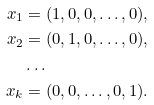<formula> <loc_0><loc_0><loc_500><loc_500>x _ { 1 } & = ( 1 , 0 , 0 , \dots , 0 ) , \\ x _ { 2 } & = ( 0 , 1 , 0 , \dots , 0 ) , \\ & \dots \\ x _ { k } & = ( 0 , 0 , \dots , 0 , 1 ) .</formula> 